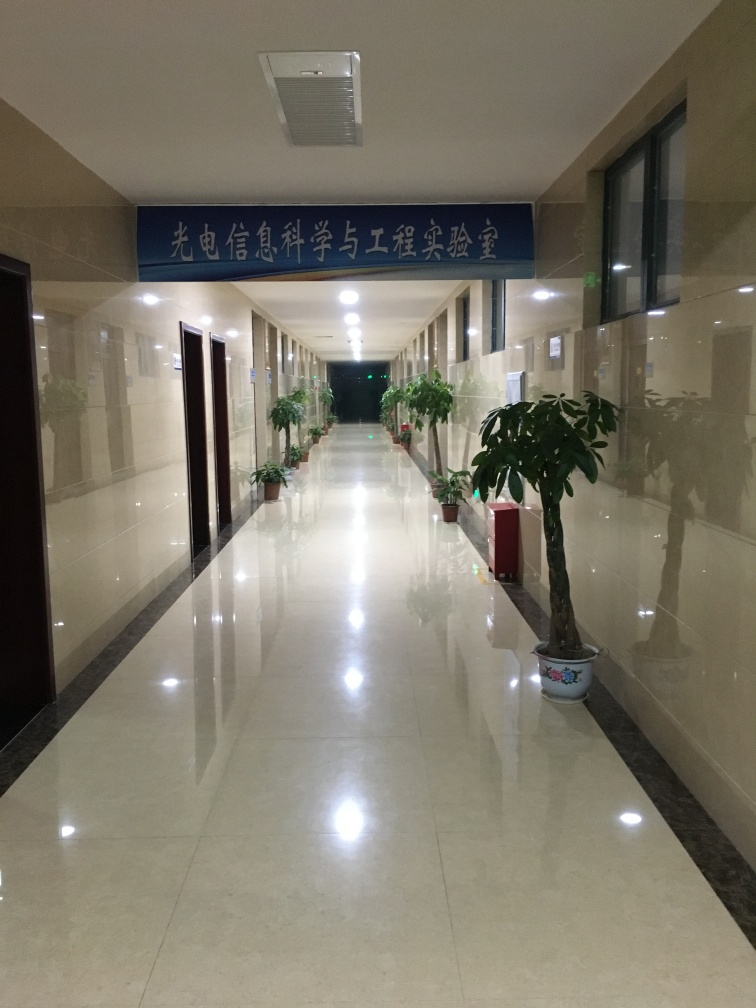Are there any quality issues with this image? The image appears to be overexposed with unbalanced lighting, leading to a lack of detail in the brighter areas. There is also a noticeable tilt to the right, which can be corrected with photo editing tools to improve the composition. Furthermore, considering the context, the image might lack a clear subject which makes it hard to understand the intent or focus of the photograph. 